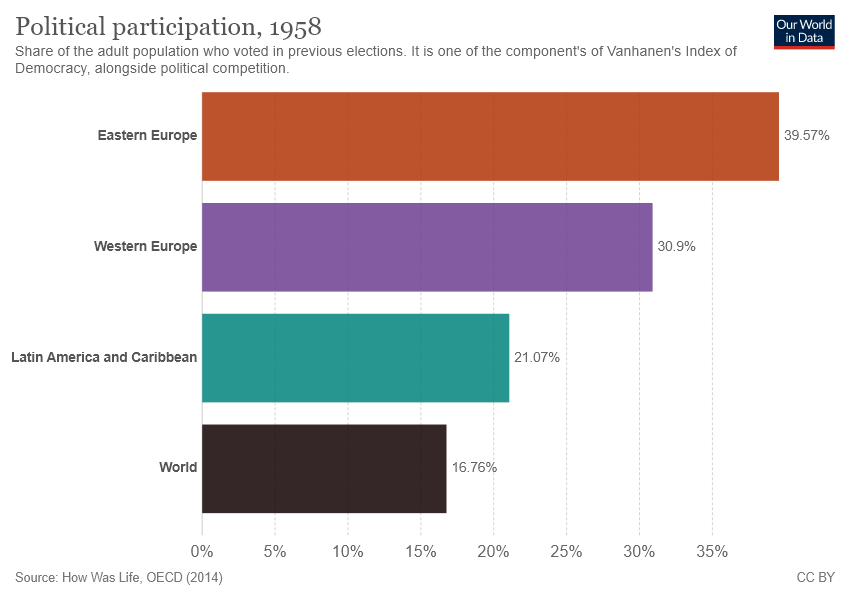Draw attention to some important aspects in this diagram. The sum of Latin American and Caribbean and the world is 37.83 and rising. Eastern Europe has the highest number of voters. 